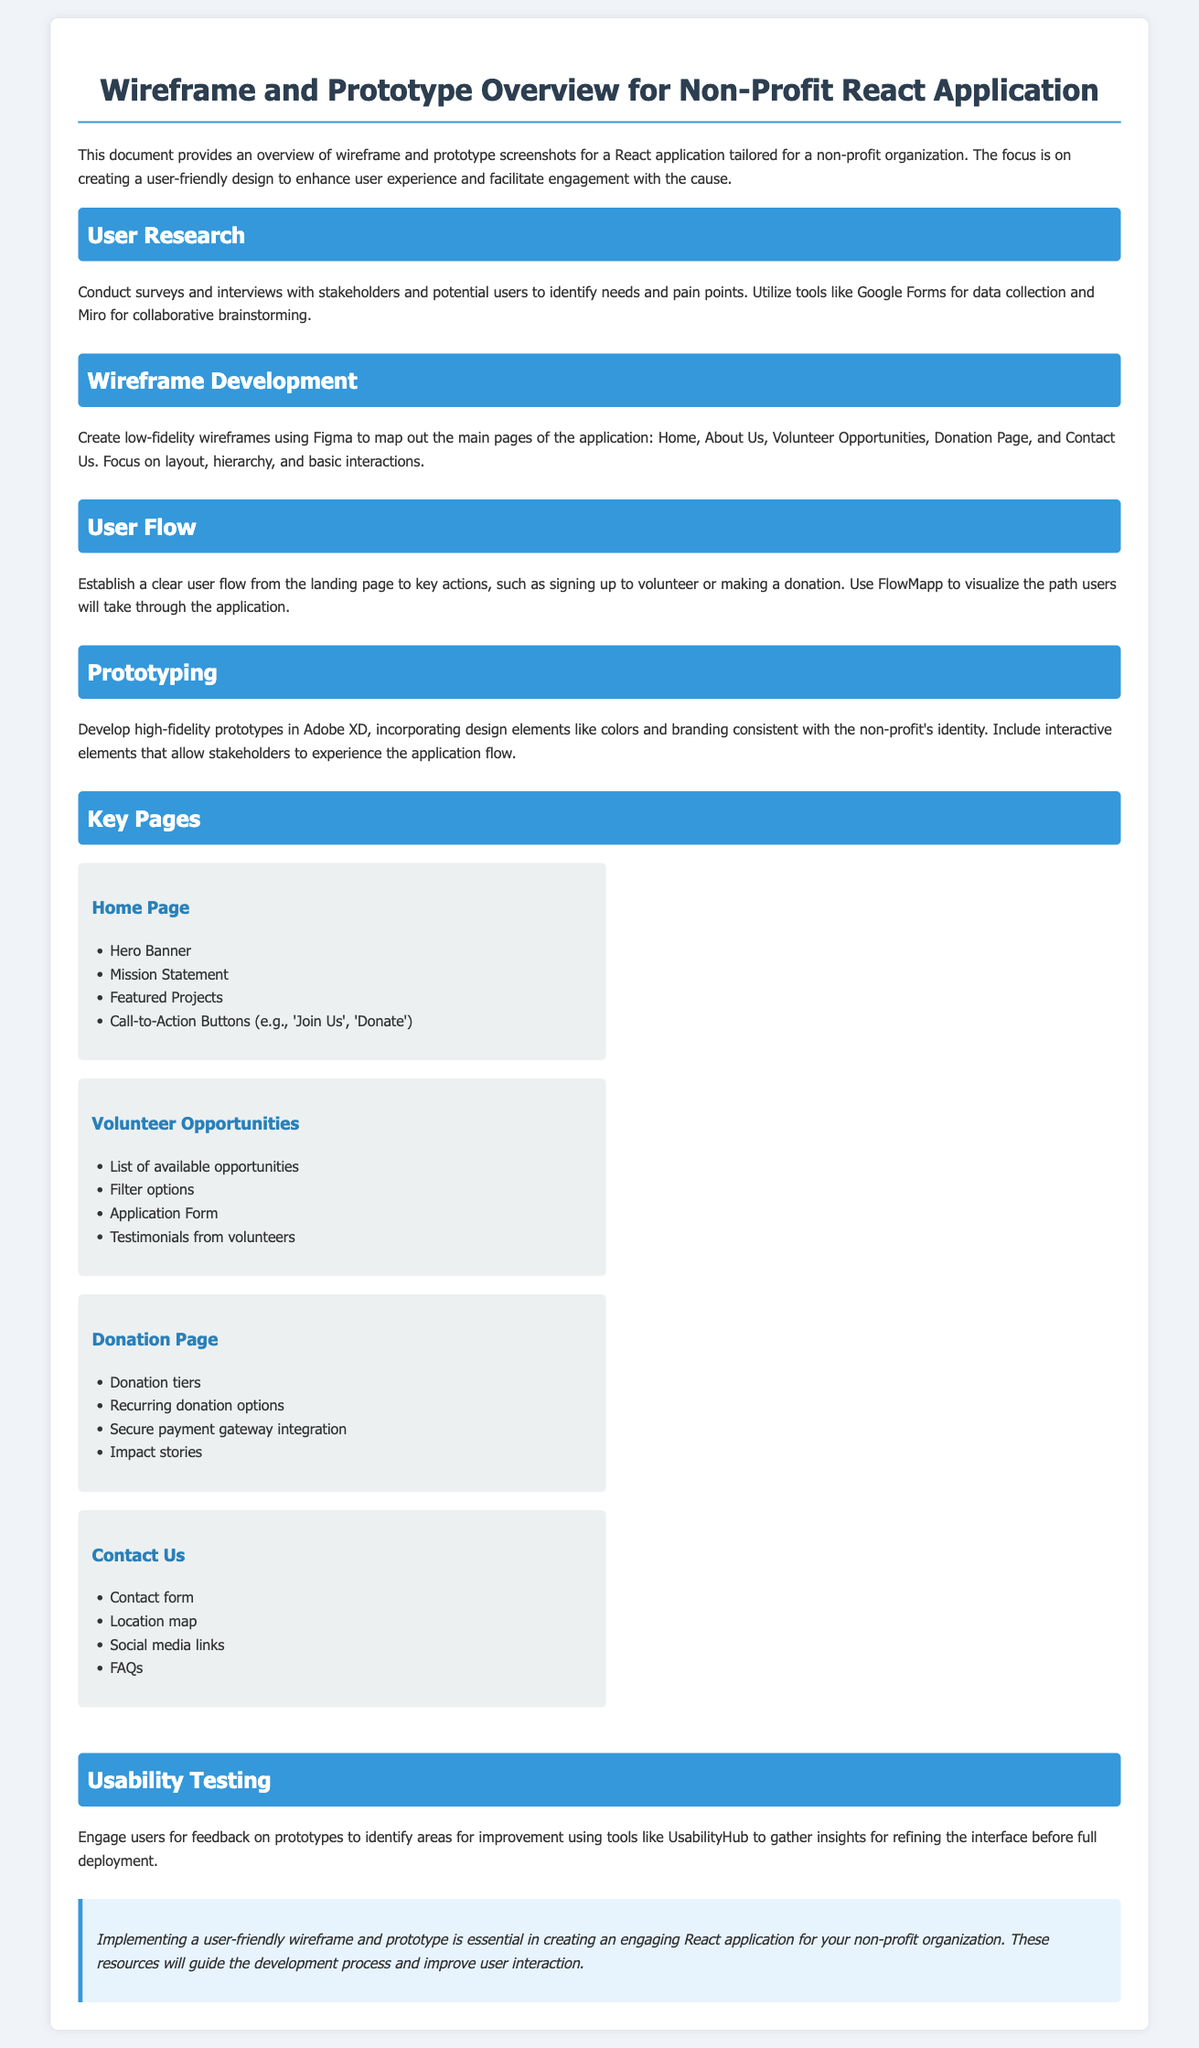what is the title of the document? The title of the document is found in the header section, summarizing its content.
Answer: Wireframe and Prototype Overview for Non-Profit React Application how many key pages are listed? The document mentions specific main pages, showcasing them in a section.
Answer: Four which tool is used for wireframe development? The document specifies the tool mentioned for creating low-fidelity wireframes.
Answer: Figma what page includes a contact form? The document identifies pages that contain specific features, including contact methods.
Answer: Contact Us what is the main focus of the wireframe and prototype? The overarching goal is stated in the opening paragraph, clarifying the intention of the design.
Answer: User-friendly design which section mentions usability testing? The document includes various sections, with one dedicated specifically to testing methods.
Answer: Usability Testing what type of opportunities are listed on the Volunteer Opportunities page? The document details the content found on the Volunteer Opportunities page, specifically focusing on opportunities.
Answer: Available opportunities which tool is suggested for user research? The document suggests a specific tool for conducting surveys and interviews in the user research section.
Answer: Google Forms 